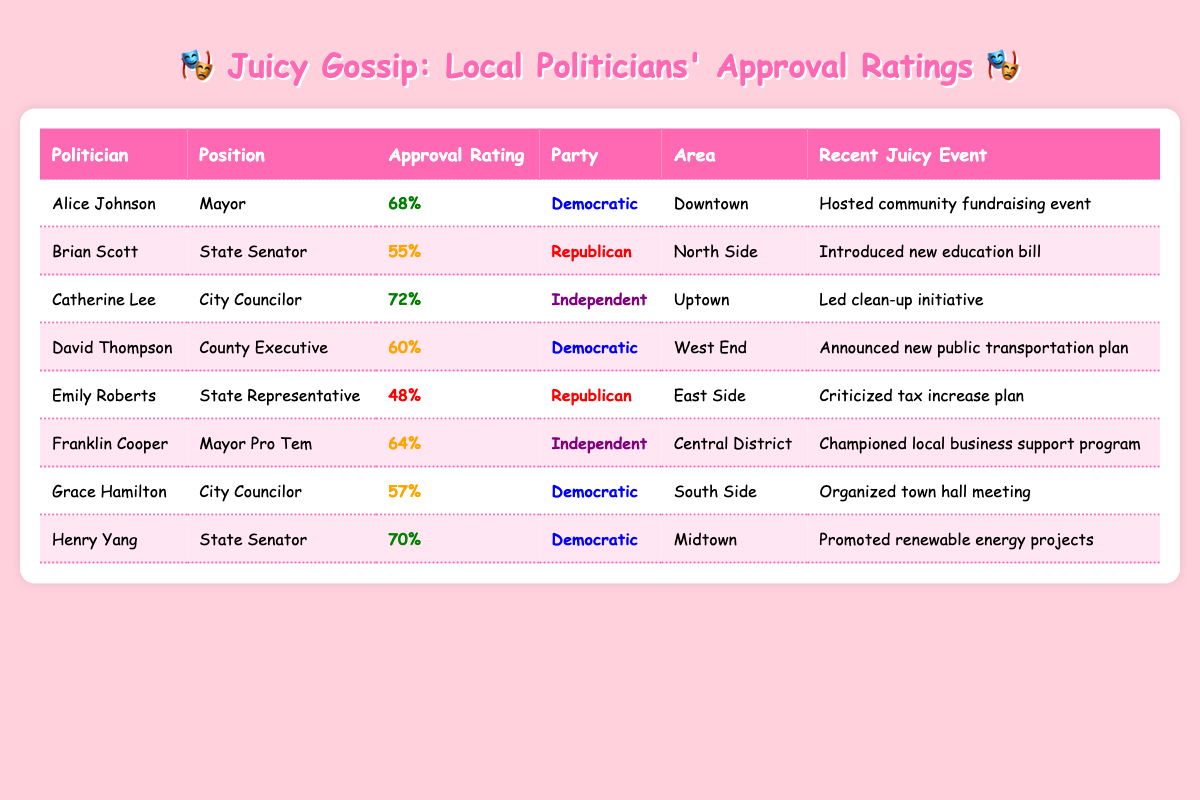What is the highest approval rating among the politicians listed? The table shows the approval ratings for all politicians. By scanning the ratings, I see that Catherine Lee has the highest rating of 72%.
Answer: 72% Which politician represents the Democratic party with the lowest approval rating? The Democratic politicians listed are Alice Johnson with 68%, David Thompson with 60%, and Grace Hamilton with 57%. The lowest among them is Grace Hamilton with an approval rating of 57%.
Answer: Grace Hamilton What was the recent event for Henry Yang? The table indicates that Henry Yang promoted renewable energy projects as his recent event.
Answer: Promoted renewable energy projects How many politicians have an approval rating above 60%? The politicians with ratings above 60% are Alice Johnson (68%), Catherine Lee (72%), Franklin Cooper (64%), and Henry Yang (70%). This totals 4 politicians.
Answer: 4 Is Emily Roberts' approval rating below 50%? Looking at the approval ratings, Emily Roberts has an approval rating of 48%, which is indeed below 50%.
Answer: Yes What is the difference between the highest approval rating and the lowest rating among the politicians? The highest rating is 72% (Catherine Lee) and the lowest is 48% (Emily Roberts). The difference is 72 - 48 = 24.
Answer: 24 Which area does David Thompson represent? The table shows that David Thompson represents the West End area.
Answer: West End What percentage of the listed politicians are from the Democratic party? There are 8 politicians total. The Democratic politicians are Alice Johnson, David Thompson, and Grace Hamilton, which totals 3. Therefore, the percentage is (3/8) * 100 = 37.5%.
Answer: 37.5% Do more politicians have an approval rating above 65% or below 55%? The politicians above 65% are Alice Johnson (68%), Catherine Lee (72%), and Henry Yang (70%), totaling 3. Those below 55% are Emily Roberts (48%) only, totaling 1. Thus, more politicians have above 65% approval.
Answer: Above 65% Which two politicians have the same party affiliation but different approval ratings? Franklin Cooper (Independent, 64%) and Catherine Lee (Independent, 72%) share the same party affiliation as Independents but have different approval ratings.
Answer: Franklin Cooper and Catherine Lee 